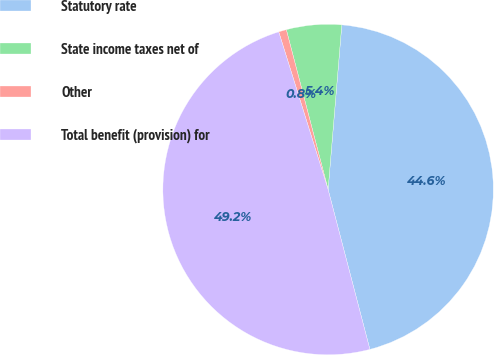Convert chart. <chart><loc_0><loc_0><loc_500><loc_500><pie_chart><fcel>Statutory rate<fcel>State income taxes net of<fcel>Other<fcel>Total benefit (provision) for<nl><fcel>44.61%<fcel>5.39%<fcel>0.76%<fcel>49.24%<nl></chart> 